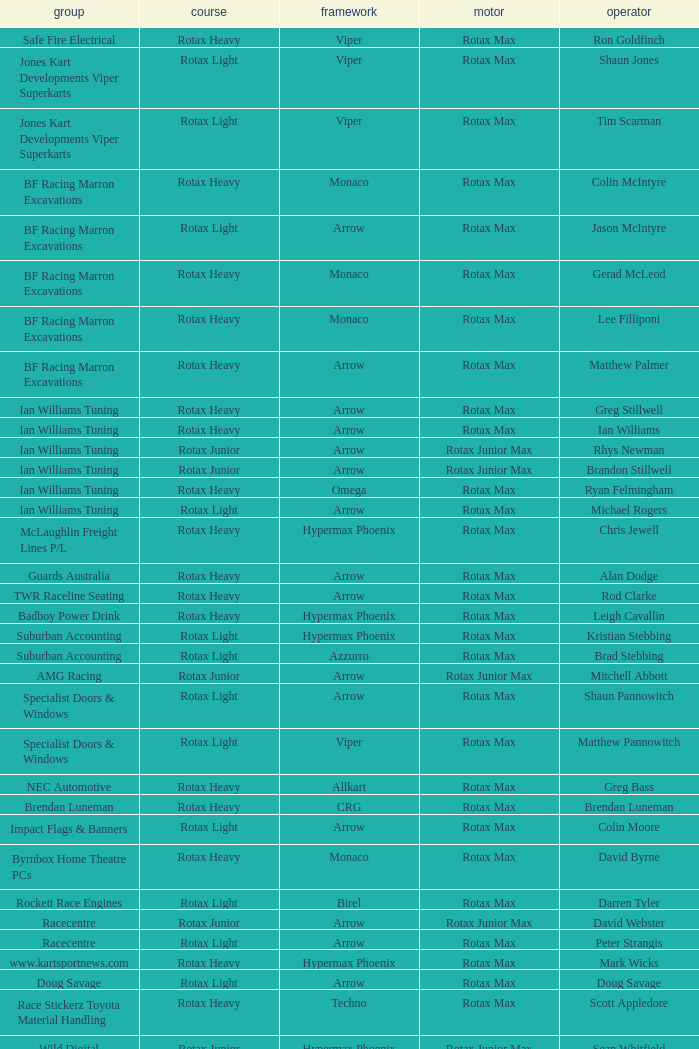What type of engine does the BF Racing Marron Excavations have that also has Monaco as chassis and Lee Filliponi as the driver? Rotax Max. 